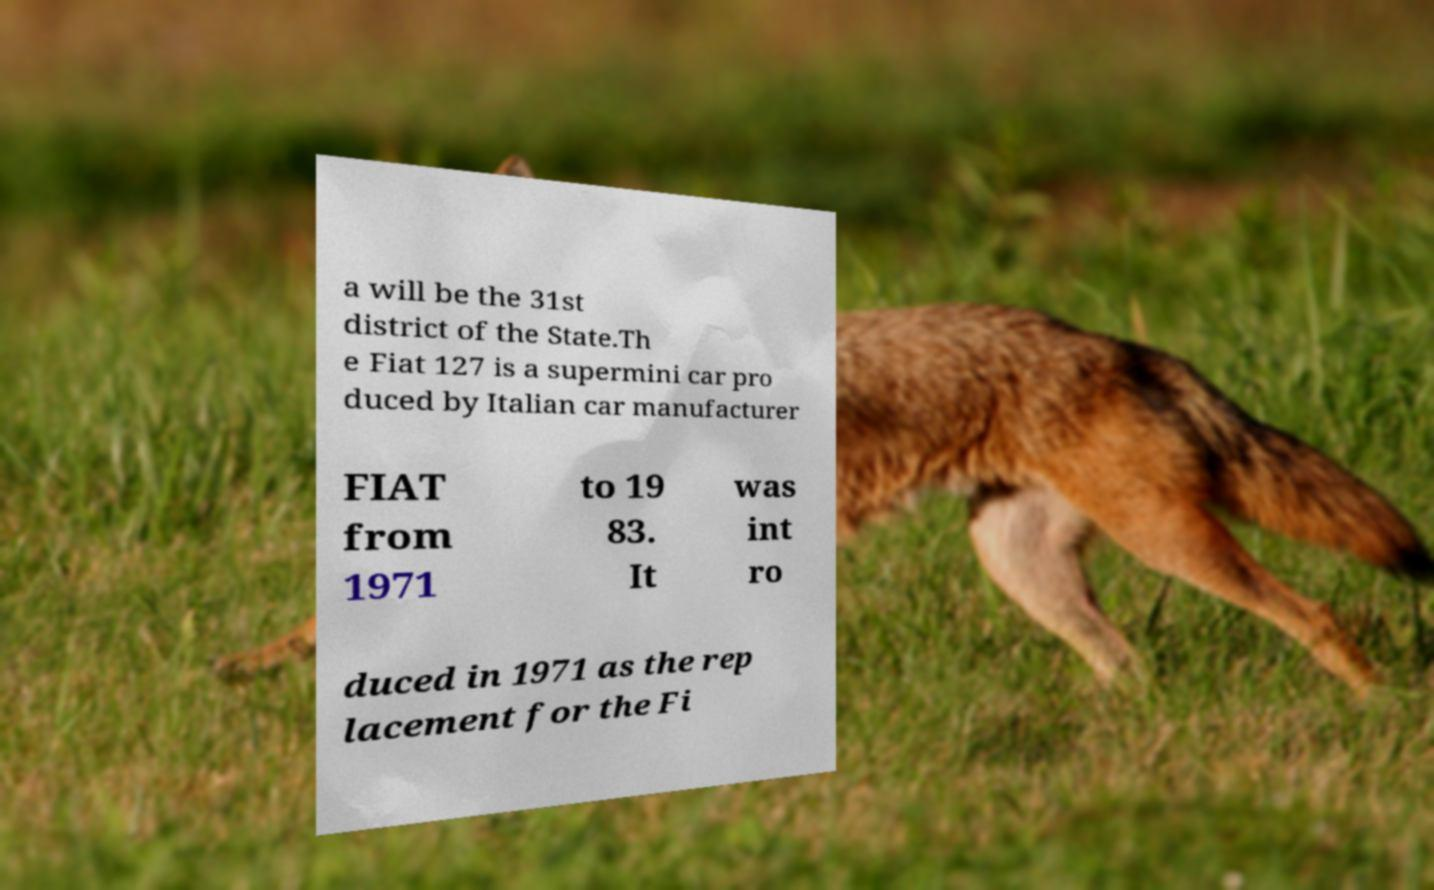Could you assist in decoding the text presented in this image and type it out clearly? a will be the 31st district of the State.Th e Fiat 127 is a supermini car pro duced by Italian car manufacturer FIAT from 1971 to 19 83. It was int ro duced in 1971 as the rep lacement for the Fi 